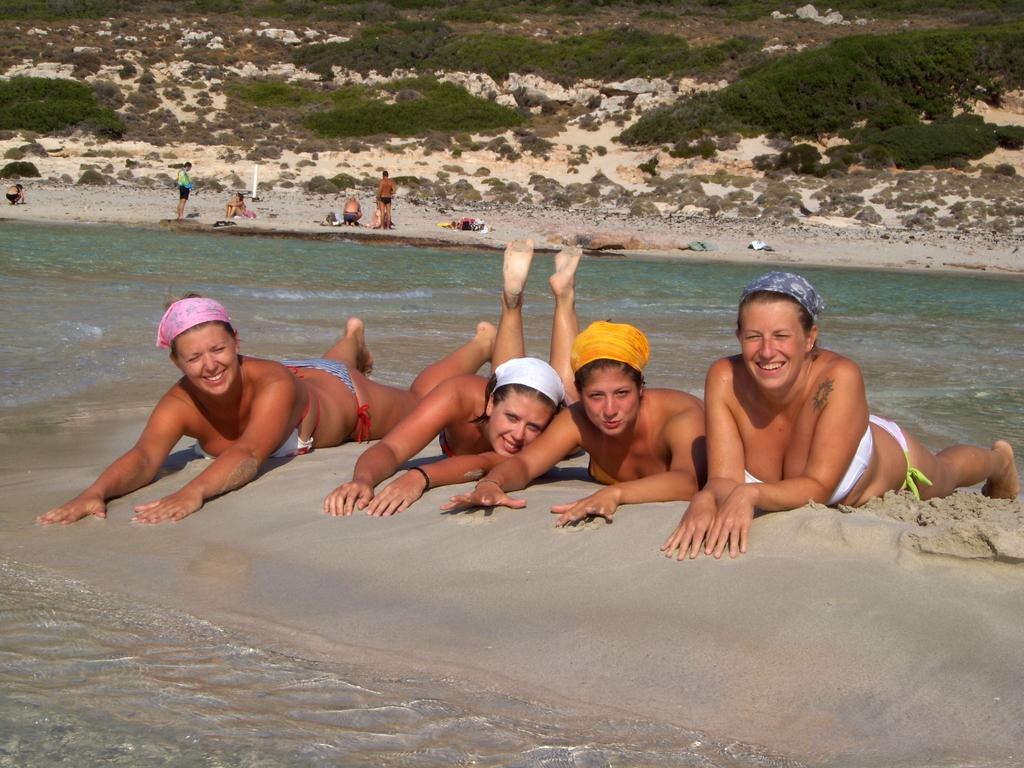How many women are laying on the sand in the image? There are four women laying on the sand in the image. What is visible behind the women? There is water visible behind the women. What are some people doing in the water? There are people standing in the water. Can you describe the position of some people in the image? There are people in a squat position. What type of vegetation is present in the image? Plants are present in the image. What type of reward can be seen in the hands of the people in the squat position? There is no reward visible in the hands of the people in the squat position, as the image does not depict any rewards. 